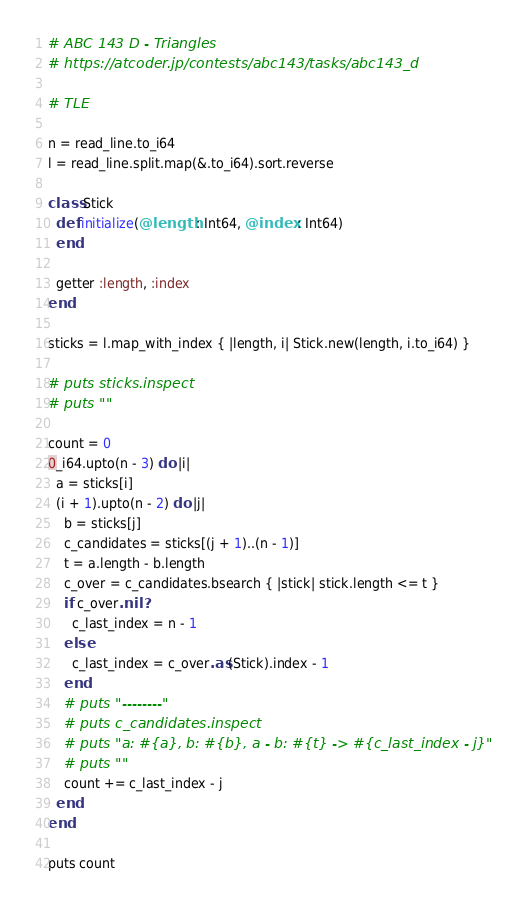<code> <loc_0><loc_0><loc_500><loc_500><_Crystal_># ABC 143 D - Triangles
# https://atcoder.jp/contests/abc143/tasks/abc143_d

# TLE

n = read_line.to_i64
l = read_line.split.map(&.to_i64).sort.reverse

class Stick
  def initialize(@length : Int64, @index : Int64)
  end

  getter :length, :index
end

sticks = l.map_with_index { |length, i| Stick.new(length, i.to_i64) }

# puts sticks.inspect
# puts ""

count = 0
0_i64.upto(n - 3) do |i|
  a = sticks[i]
  (i + 1).upto(n - 2) do |j|
    b = sticks[j]
    c_candidates = sticks[(j + 1)..(n - 1)]
    t = a.length - b.length
    c_over = c_candidates.bsearch { |stick| stick.length <= t }
    if c_over.nil?
      c_last_index = n - 1
    else
      c_last_index = c_over.as(Stick).index - 1
    end
    # puts "--------"
    # puts c_candidates.inspect
    # puts "a: #{a}, b: #{b}, a - b: #{t} -> #{c_last_index - j}"
    # puts ""
    count += c_last_index - j
  end
end

puts count
</code> 